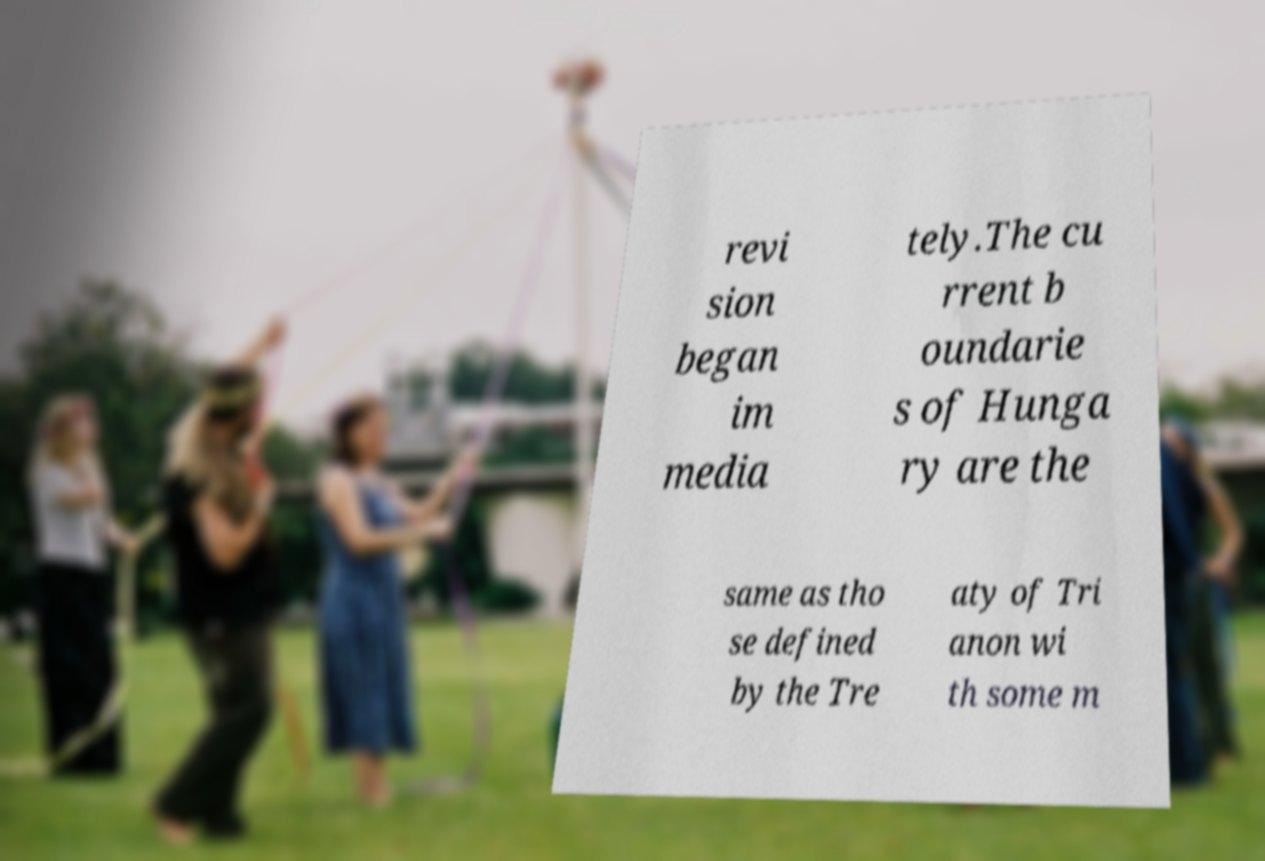What messages or text are displayed in this image? I need them in a readable, typed format. revi sion began im media tely.The cu rrent b oundarie s of Hunga ry are the same as tho se defined by the Tre aty of Tri anon wi th some m 